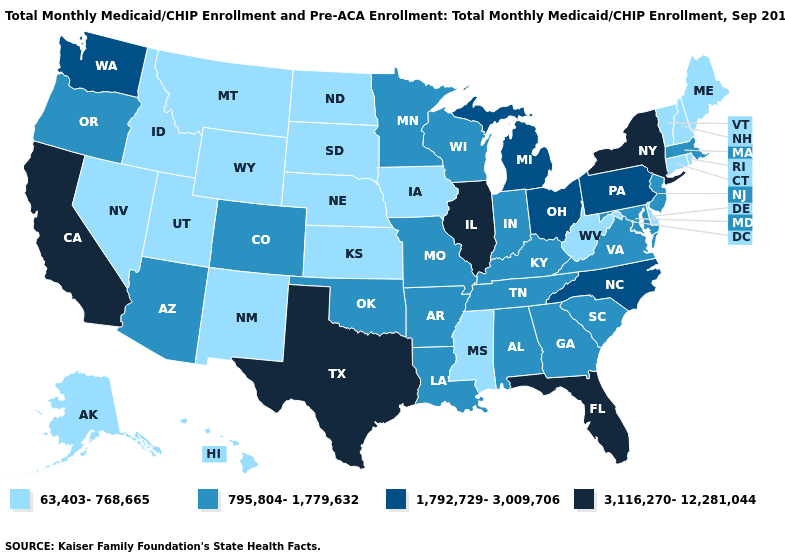What is the lowest value in states that border Idaho?
Keep it brief. 63,403-768,665. Does the first symbol in the legend represent the smallest category?
Keep it brief. Yes. Is the legend a continuous bar?
Keep it brief. No. Name the states that have a value in the range 63,403-768,665?
Give a very brief answer. Alaska, Connecticut, Delaware, Hawaii, Idaho, Iowa, Kansas, Maine, Mississippi, Montana, Nebraska, Nevada, New Hampshire, New Mexico, North Dakota, Rhode Island, South Dakota, Utah, Vermont, West Virginia, Wyoming. Which states have the lowest value in the MidWest?
Write a very short answer. Iowa, Kansas, Nebraska, North Dakota, South Dakota. Name the states that have a value in the range 1,792,729-3,009,706?
Short answer required. Michigan, North Carolina, Ohio, Pennsylvania, Washington. Does Maine have a lower value than Vermont?
Short answer required. No. What is the value of Alaska?
Write a very short answer. 63,403-768,665. Name the states that have a value in the range 795,804-1,779,632?
Be succinct. Alabama, Arizona, Arkansas, Colorado, Georgia, Indiana, Kentucky, Louisiana, Maryland, Massachusetts, Minnesota, Missouri, New Jersey, Oklahoma, Oregon, South Carolina, Tennessee, Virginia, Wisconsin. What is the value of Oklahoma?
Quick response, please. 795,804-1,779,632. What is the value of Florida?
Quick response, please. 3,116,270-12,281,044. Does the first symbol in the legend represent the smallest category?
Answer briefly. Yes. What is the value of Rhode Island?
Keep it brief. 63,403-768,665. Name the states that have a value in the range 1,792,729-3,009,706?
Be succinct. Michigan, North Carolina, Ohio, Pennsylvania, Washington. What is the value of California?
Write a very short answer. 3,116,270-12,281,044. 